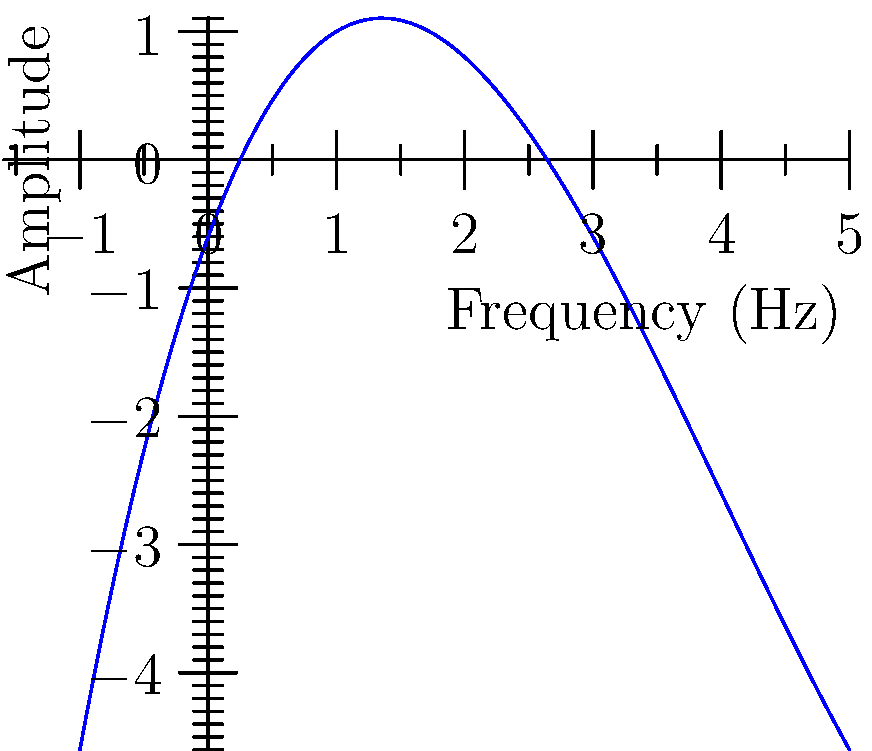A trap beat's frequency spectrum can be modeled by the polynomial function $f(x) = 0.1x^3 - 1.2x^2 + 2.7x - 0.6$, where $x$ represents frequency in Hz and $f(x)$ represents amplitude. Find the frequencies at which the amplitude of the beat is zero. To find the frequencies where the amplitude is zero, we need to solve the equation:

$0.1x^3 - 1.2x^2 + 2.7x - 0.6 = 0$

This is a cubic equation. We can solve it using the following steps:

1) First, let's check if there are any rational roots using the rational root theorem. The possible rational roots are factors of the constant term: ±1, ±2, ±3, ±6.

2) By testing these values, we find that $x = 1$ is a root.

3) We can factor out $(x - 1)$:

   $0.1x^3 - 1.2x^2 + 2.7x - 0.6 = 0.1(x - 1)(x^2 - 2x + 6)$

4) Now we need to solve $x^2 - 2x + 6 = 0$

5) This is a quadratic equation. We can solve it using the quadratic formula:
   $x = \frac{-b \pm \sqrt{b^2 - 4ac}}{2a}$

   Where $a = 1$, $b = -2$, and $c = 6$

6) Plugging in these values:
   $x = \frac{2 \pm \sqrt{4 - 24}}{2} = \frac{2 \pm \sqrt{-20}}{2} = 1 \pm i\sqrt{5}$

7) Therefore, the roots are:
   $x_1 = 1$
   $x_2 = 1 + i\sqrt{5}$
   $x_3 = 1 - i\sqrt{5}$

8) Since frequency must be real, the only valid solution is $x = 1$ Hz.
Answer: 1 Hz 